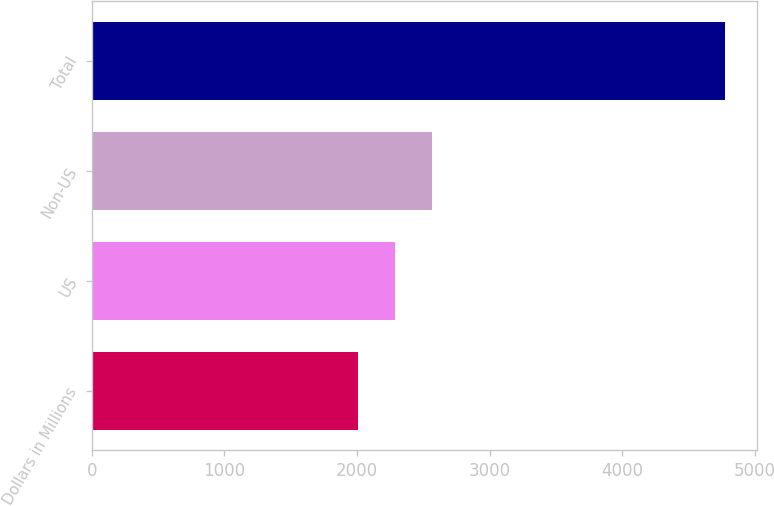<chart> <loc_0><loc_0><loc_500><loc_500><bar_chart><fcel>Dollars in Millions<fcel>US<fcel>Non-US<fcel>Total<nl><fcel>2008<fcel>2284.8<fcel>2561.6<fcel>4776<nl></chart> 